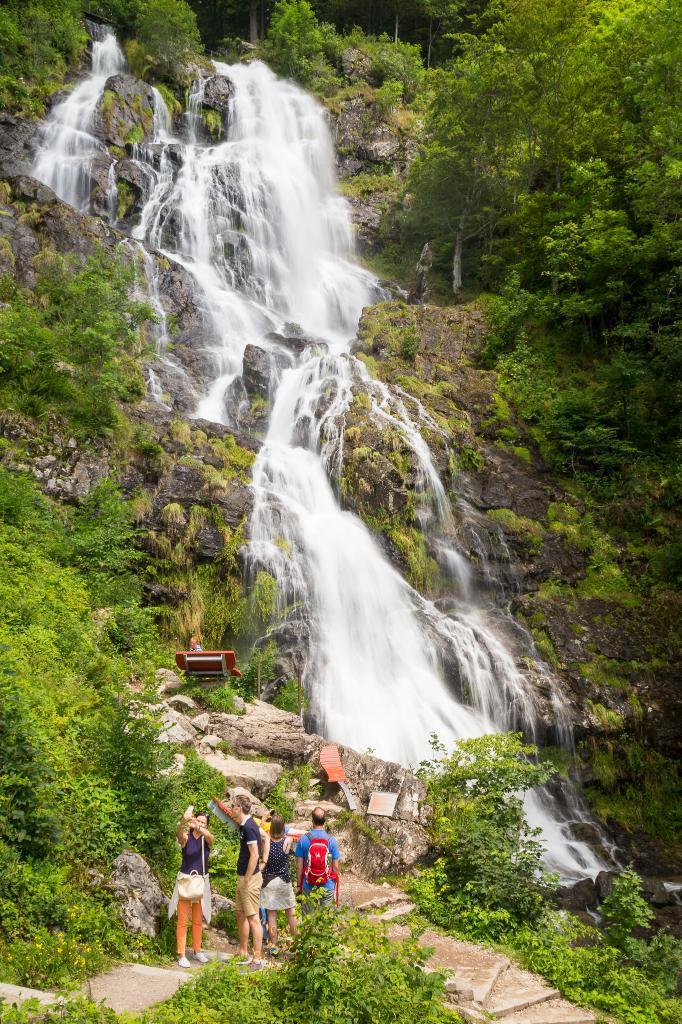Please provide a concise description of this image. In this image we can see these people are standing here. Here we can see the stairs, trees, bench, rocks, waterfall from the hills. 